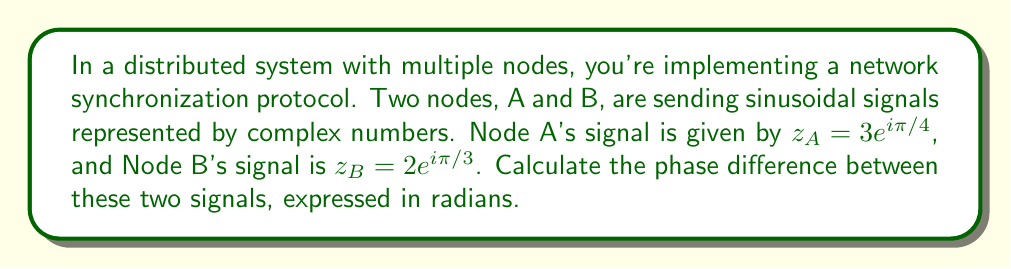Can you solve this math problem? To solve this problem, we'll follow these steps:

1) Recall that for a complex number in the form $z = re^{i\theta}$, $\theta$ represents the phase angle.

2) For Node A: $z_A = 3e^{i\pi/4}$
   The phase angle for A is $\theta_A = \pi/4$ radians.

3) For Node B: $z_B = 2e^{i\pi/3}$
   The phase angle for B is $\theta_B = \pi/3$ radians.

4) The phase difference is calculated by subtracting the phase angles:

   $$\Delta\theta = \theta_B - \theta_A = \frac{\pi}{3} - \frac{\pi}{4}$$

5) To simplify this:
   $$\Delta\theta = \frac{4\pi}{12} - \frac{3\pi}{12} = \frac{\pi}{12}$$

Therefore, the phase difference between the two signals is $\frac{\pi}{12}$ radians.
Answer: $\frac{\pi}{12}$ radians 